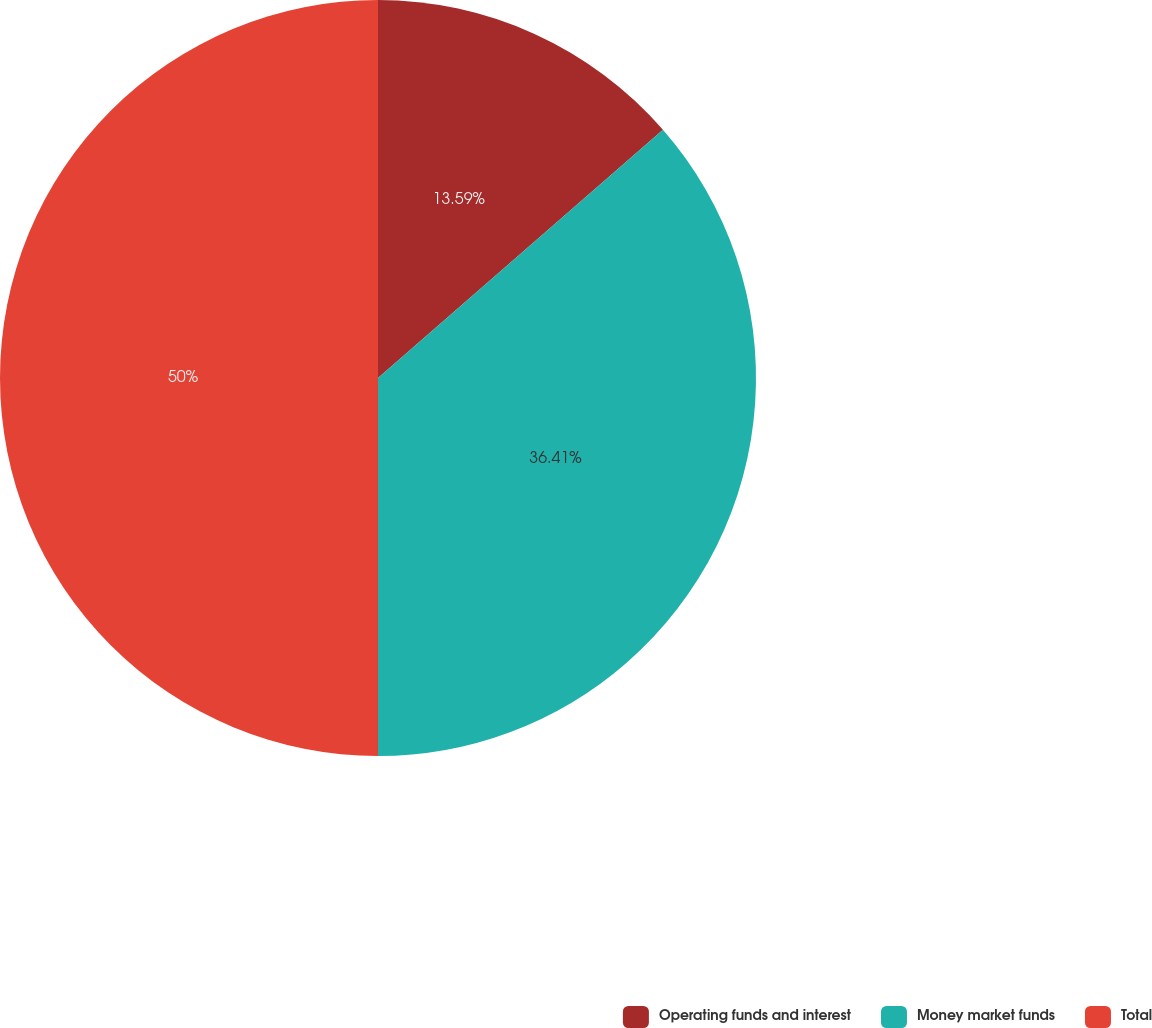<chart> <loc_0><loc_0><loc_500><loc_500><pie_chart><fcel>Operating funds and interest<fcel>Money market funds<fcel>Total<nl><fcel>13.59%<fcel>36.41%<fcel>50.0%<nl></chart> 